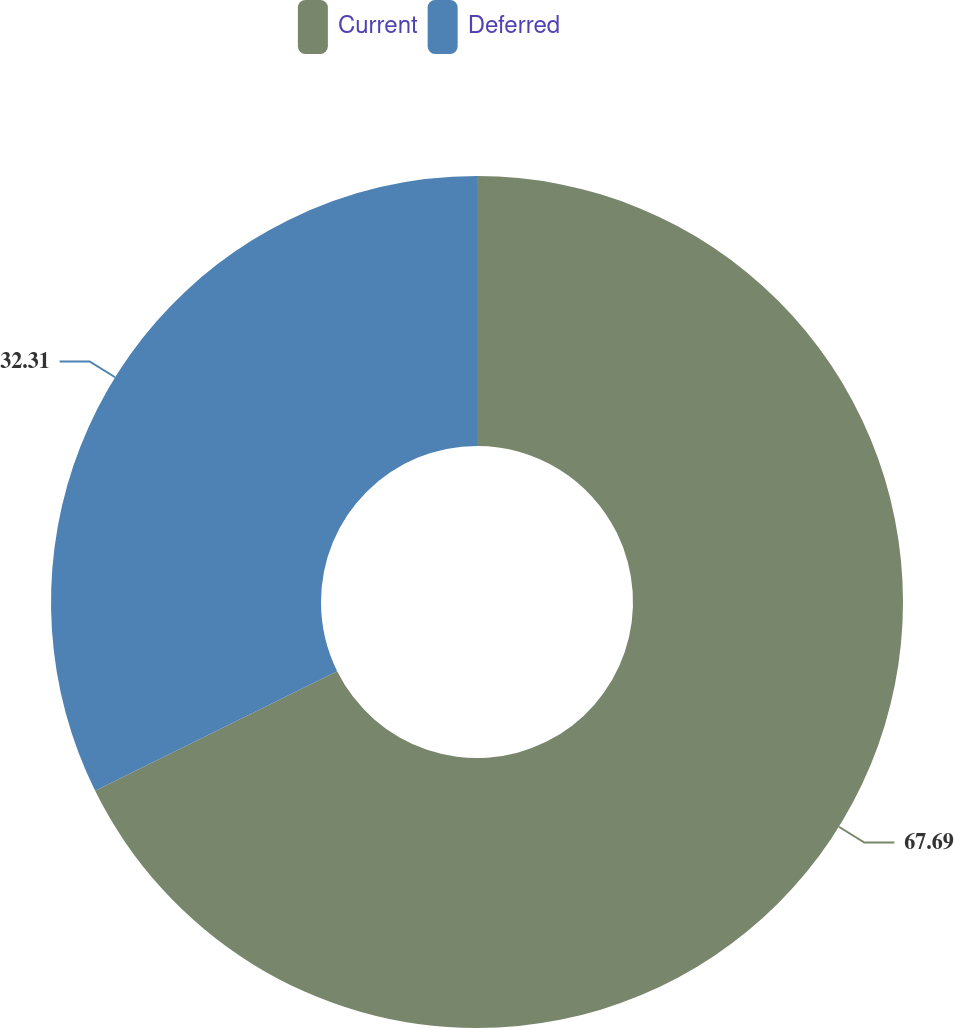Convert chart. <chart><loc_0><loc_0><loc_500><loc_500><pie_chart><fcel>Current<fcel>Deferred<nl><fcel>67.69%<fcel>32.31%<nl></chart> 